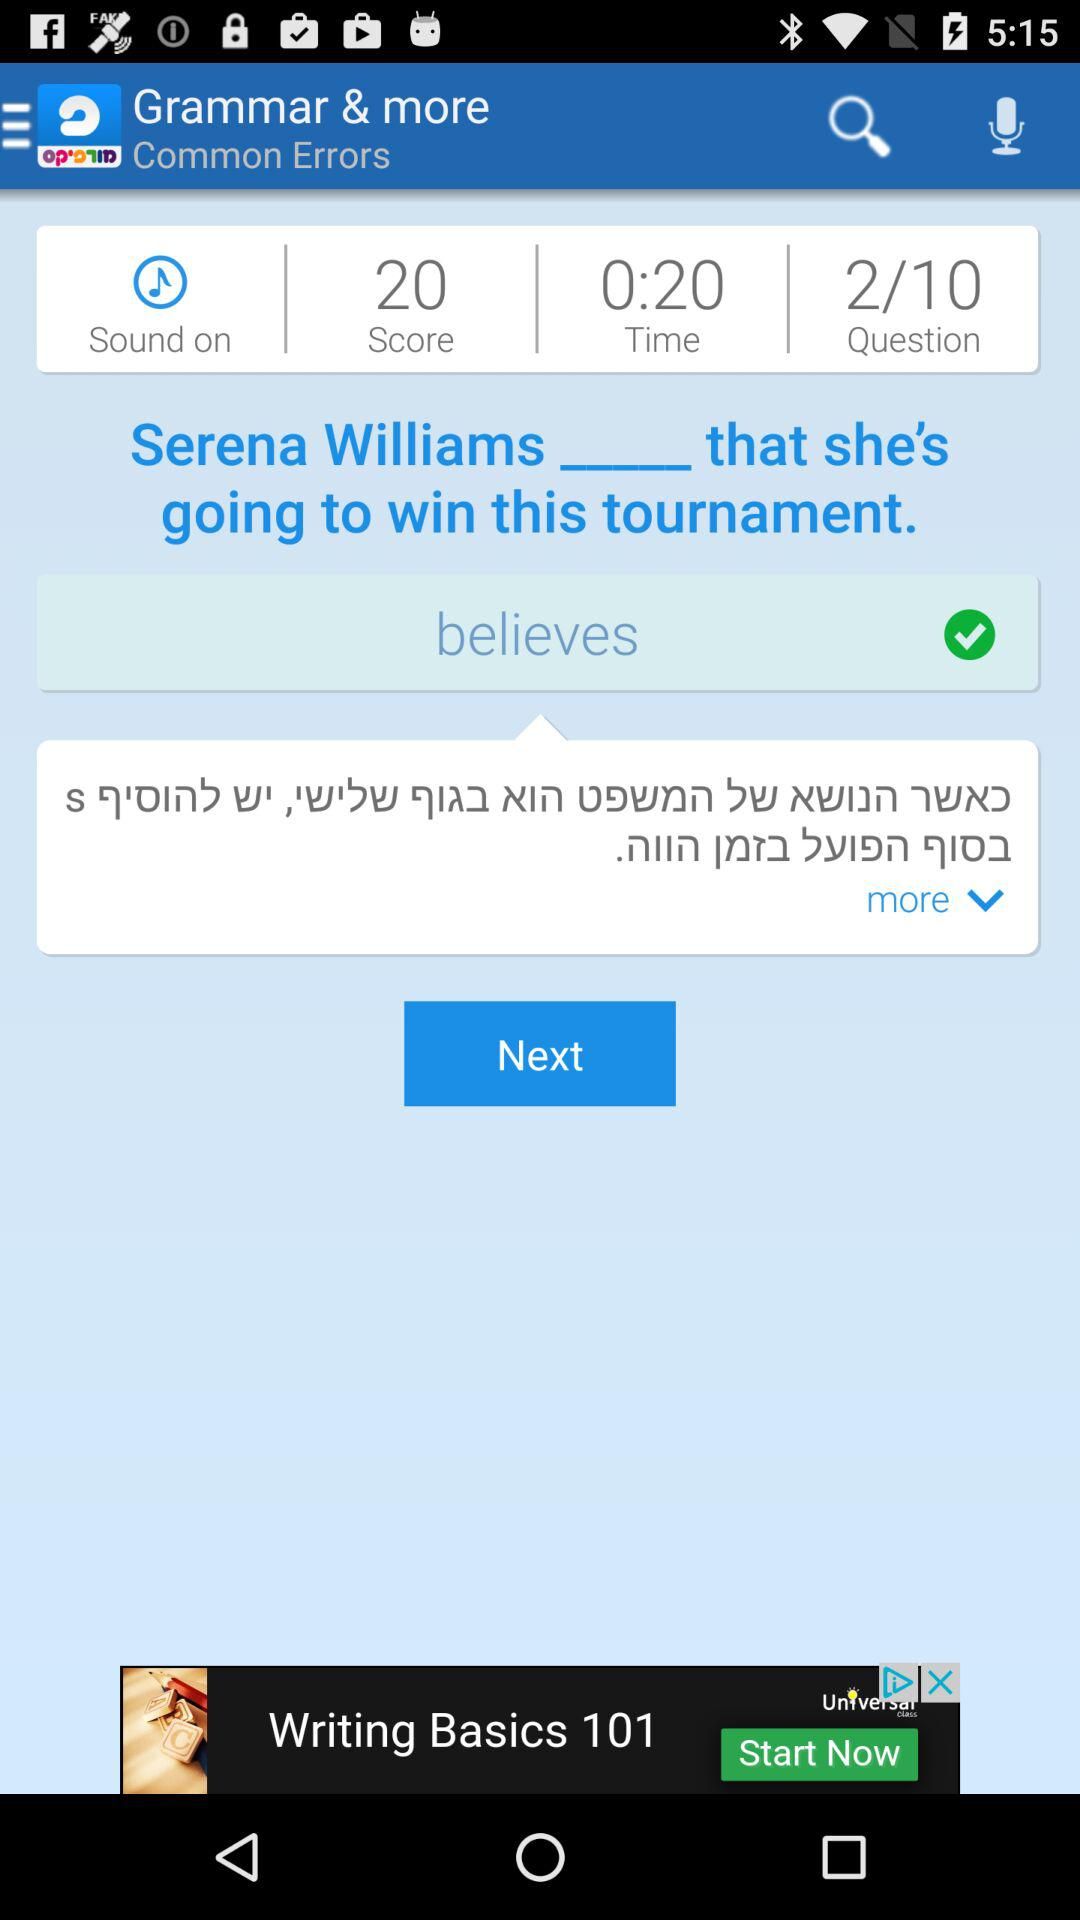Which question number am I on? You are on question number 1. 